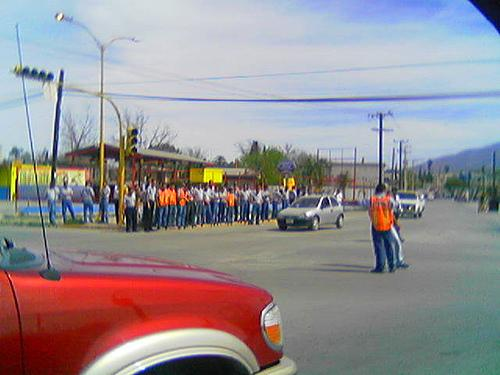What are these people doing here? protesting 